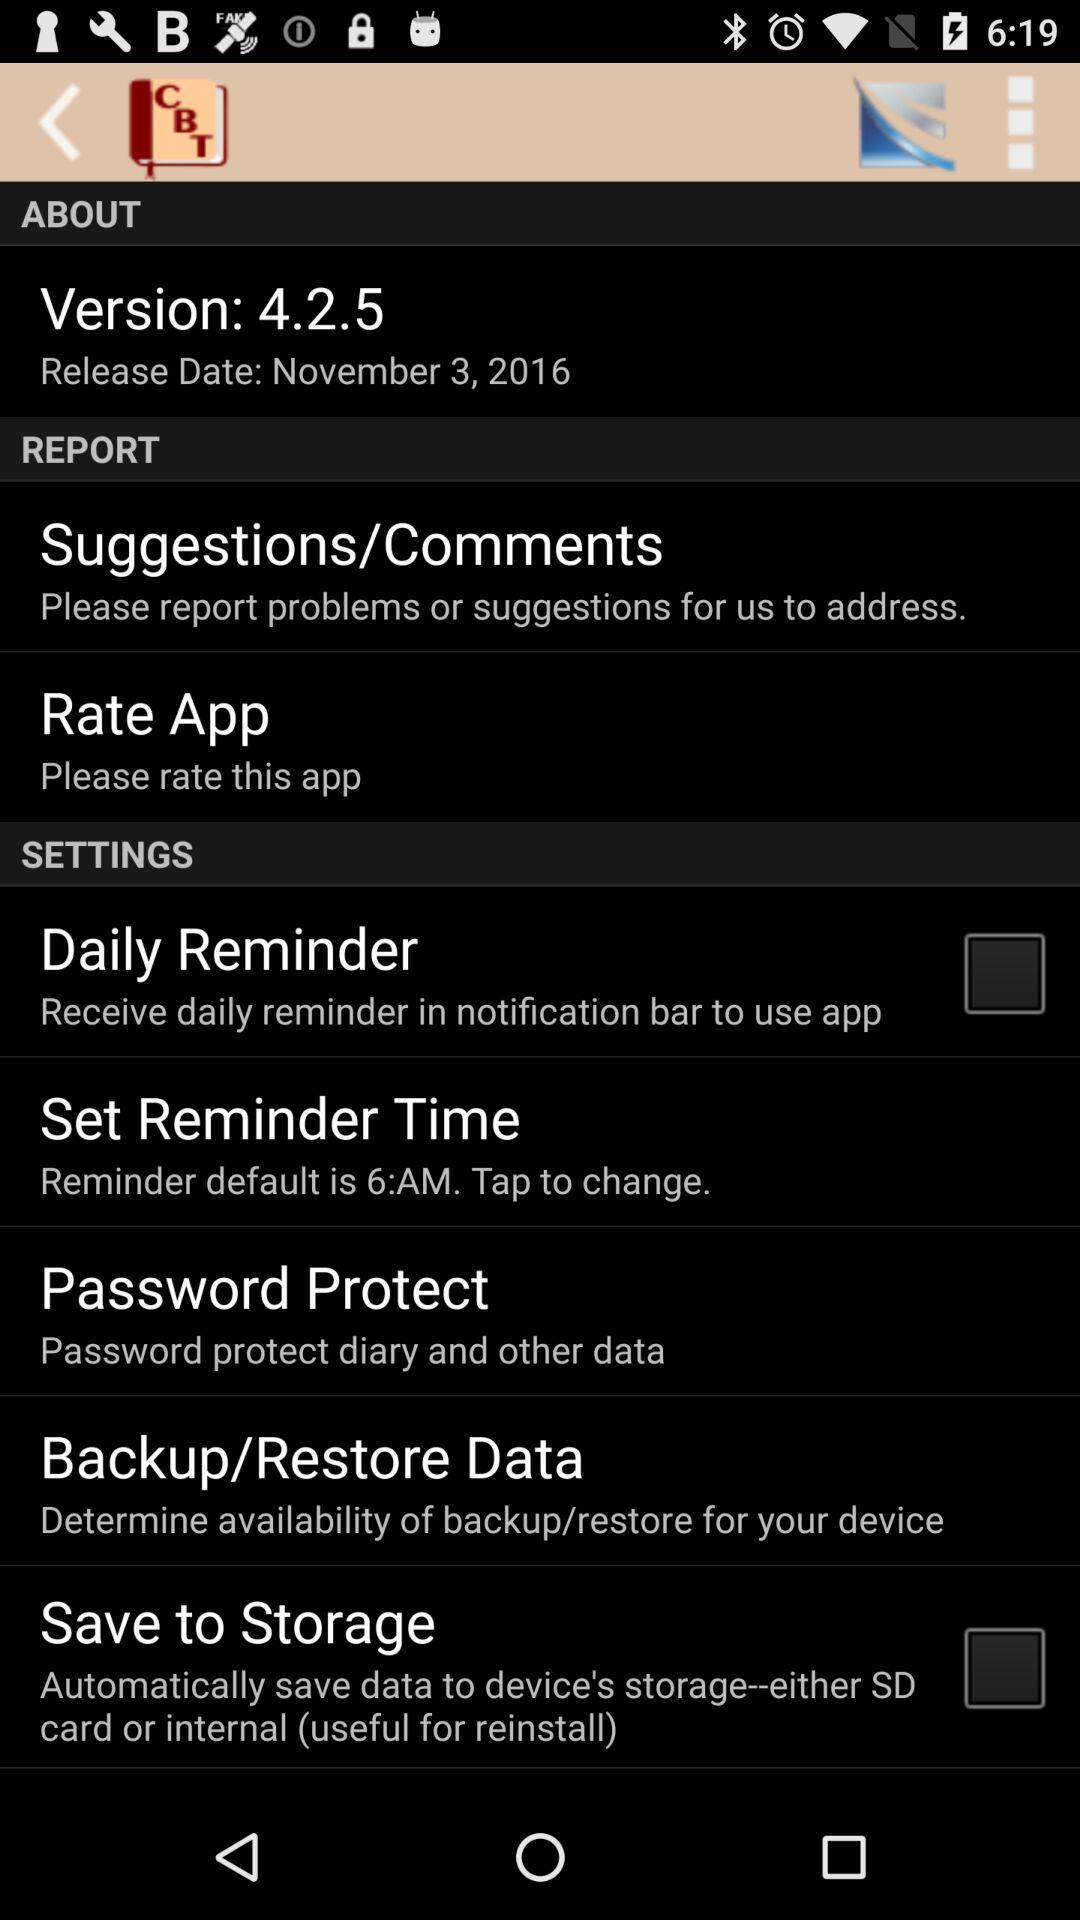What is the release date of the application? The release date of the application is November 3, 2016. 